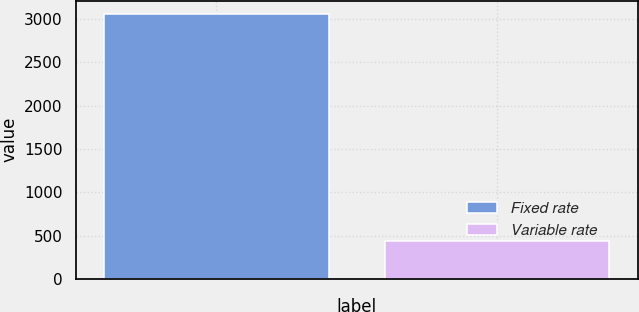Convert chart to OTSL. <chart><loc_0><loc_0><loc_500><loc_500><bar_chart><fcel>Fixed rate<fcel>Variable rate<nl><fcel>3061.1<fcel>438.5<nl></chart> 